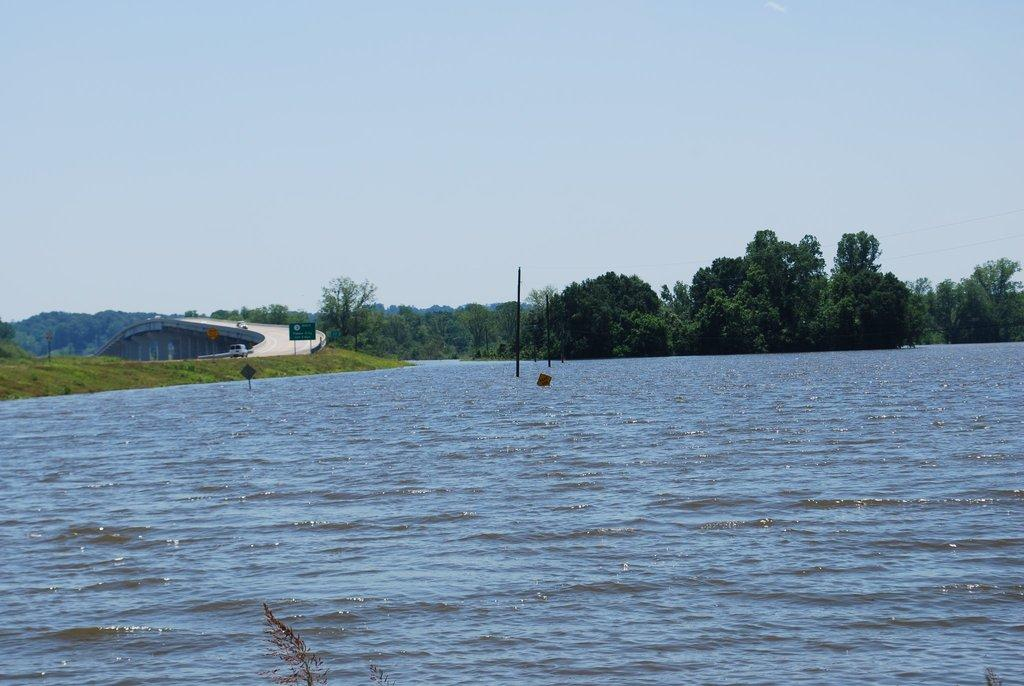What type of vegetation can be seen in the image? There are trees in the image. What structures are present in the image? There are signboards, poles, a bridge, and a blue sky visible in the image. What type of ground surface is present in the image? There is grass in the image. Is there any water visible in the image? Yes, there is water visible in the image. What color is the sky in the image? The sky is blue in color. What type of pen is being used by the trees in the image? There are no pens present in the image, as trees do not use pens. What type of learning is taking place on the bridge in the image? There is no learning activity depicted on the bridge in the image. 